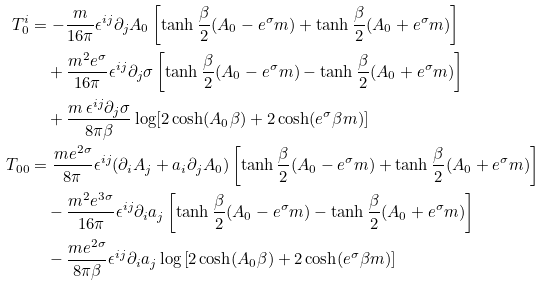Convert formula to latex. <formula><loc_0><loc_0><loc_500><loc_500>T _ { 0 } ^ { i } & = - \frac { m } { 1 6 \pi } \epsilon ^ { i j } \partial _ { j } A _ { 0 } \left [ \tanh \frac { \beta } { 2 } ( A _ { 0 } - e ^ { \sigma } m ) + \tanh \frac { \beta } { 2 } ( A _ { 0 } + e ^ { \sigma } m ) \right ] \\ & \quad + \frac { m ^ { 2 } e ^ { \sigma } } { 1 6 \pi } \epsilon ^ { i j } \partial _ { j } \sigma \left [ \tanh \frac { \beta } { 2 } ( A _ { 0 } - e ^ { \sigma } m ) - \tanh \frac { \beta } { 2 } ( A _ { 0 } + e ^ { \sigma } m ) \right ] \\ & \quad + \frac { m \, \epsilon ^ { i j } \partial _ { j } \sigma } { 8 \pi \beta } \log [ 2 \cosh ( A _ { 0 } \beta ) + 2 \cosh ( e ^ { \sigma } \beta m ) ] \\ T _ { 0 0 } & = \frac { m e ^ { 2 \sigma } } { 8 \pi } \epsilon ^ { i j } ( \partial _ { i } A _ { j } + a _ { i } \partial _ { j } A _ { 0 } ) \left [ \tanh \frac { \beta } { 2 } ( A _ { 0 } - e ^ { \sigma } m ) + \tanh \frac { \beta } { 2 } ( A _ { 0 } + e ^ { \sigma } m ) \right ] \\ & \quad - \frac { m ^ { 2 } e ^ { 3 \sigma } } { 1 6 \pi } \epsilon ^ { i j } \partial _ { i } a _ { j } \left [ \tanh \frac { \beta } { 2 } ( A _ { 0 } - e ^ { \sigma } m ) - \tanh \frac { \beta } { 2 } ( A _ { 0 } + e ^ { \sigma } m ) \right ] \\ & \quad - \frac { m e ^ { 2 \sigma } } { 8 \pi \beta } \epsilon ^ { i j } \partial _ { i } a _ { j } \log \left [ 2 \cosh ( A _ { 0 } \beta ) + 2 \cosh ( e ^ { \sigma } \beta m ) \right ] \\</formula> 